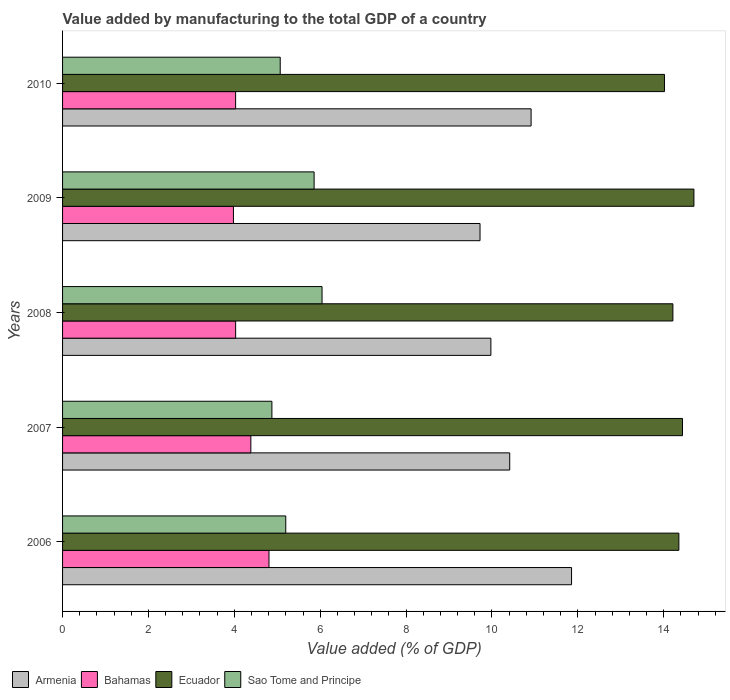How many different coloured bars are there?
Offer a very short reply. 4. How many groups of bars are there?
Your response must be concise. 5. How many bars are there on the 1st tick from the top?
Your answer should be very brief. 4. What is the value added by manufacturing to the total GDP in Ecuador in 2008?
Make the answer very short. 14.21. Across all years, what is the maximum value added by manufacturing to the total GDP in Bahamas?
Your answer should be very brief. 4.81. Across all years, what is the minimum value added by manufacturing to the total GDP in Ecuador?
Keep it short and to the point. 14.02. In which year was the value added by manufacturing to the total GDP in Armenia maximum?
Offer a very short reply. 2006. What is the total value added by manufacturing to the total GDP in Sao Tome and Principe in the graph?
Give a very brief answer. 27.04. What is the difference between the value added by manufacturing to the total GDP in Sao Tome and Principe in 2009 and that in 2010?
Your response must be concise. 0.79. What is the difference between the value added by manufacturing to the total GDP in Bahamas in 2010 and the value added by manufacturing to the total GDP in Sao Tome and Principe in 2008?
Your answer should be very brief. -2.01. What is the average value added by manufacturing to the total GDP in Sao Tome and Principe per year?
Ensure brevity in your answer.  5.41. In the year 2009, what is the difference between the value added by manufacturing to the total GDP in Sao Tome and Principe and value added by manufacturing to the total GDP in Armenia?
Provide a short and direct response. -3.86. What is the ratio of the value added by manufacturing to the total GDP in Ecuador in 2006 to that in 2010?
Your response must be concise. 1.02. What is the difference between the highest and the second highest value added by manufacturing to the total GDP in Sao Tome and Principe?
Offer a very short reply. 0.18. What is the difference between the highest and the lowest value added by manufacturing to the total GDP in Bahamas?
Your response must be concise. 0.83. What does the 1st bar from the top in 2010 represents?
Offer a very short reply. Sao Tome and Principe. What does the 1st bar from the bottom in 2007 represents?
Give a very brief answer. Armenia. How many bars are there?
Give a very brief answer. 20. What is the difference between two consecutive major ticks on the X-axis?
Offer a very short reply. 2. Does the graph contain any zero values?
Make the answer very short. No. Where does the legend appear in the graph?
Your answer should be compact. Bottom left. How many legend labels are there?
Your answer should be compact. 4. What is the title of the graph?
Ensure brevity in your answer.  Value added by manufacturing to the total GDP of a country. Does "Palau" appear as one of the legend labels in the graph?
Give a very brief answer. No. What is the label or title of the X-axis?
Provide a short and direct response. Value added (% of GDP). What is the Value added (% of GDP) in Armenia in 2006?
Provide a short and direct response. 11.85. What is the Value added (% of GDP) in Bahamas in 2006?
Offer a terse response. 4.81. What is the Value added (% of GDP) in Ecuador in 2006?
Your answer should be compact. 14.35. What is the Value added (% of GDP) of Sao Tome and Principe in 2006?
Offer a very short reply. 5.2. What is the Value added (% of GDP) of Armenia in 2007?
Offer a terse response. 10.41. What is the Value added (% of GDP) in Bahamas in 2007?
Give a very brief answer. 4.38. What is the Value added (% of GDP) of Ecuador in 2007?
Give a very brief answer. 14.44. What is the Value added (% of GDP) of Sao Tome and Principe in 2007?
Offer a terse response. 4.88. What is the Value added (% of GDP) in Armenia in 2008?
Give a very brief answer. 9.98. What is the Value added (% of GDP) in Bahamas in 2008?
Provide a succinct answer. 4.03. What is the Value added (% of GDP) in Ecuador in 2008?
Offer a very short reply. 14.21. What is the Value added (% of GDP) in Sao Tome and Principe in 2008?
Your answer should be very brief. 6.04. What is the Value added (% of GDP) in Armenia in 2009?
Offer a very short reply. 9.72. What is the Value added (% of GDP) in Bahamas in 2009?
Your answer should be very brief. 3.98. What is the Value added (% of GDP) in Ecuador in 2009?
Offer a very short reply. 14.7. What is the Value added (% of GDP) in Sao Tome and Principe in 2009?
Your answer should be very brief. 5.86. What is the Value added (% of GDP) of Armenia in 2010?
Make the answer very short. 10.91. What is the Value added (% of GDP) in Bahamas in 2010?
Give a very brief answer. 4.03. What is the Value added (% of GDP) in Ecuador in 2010?
Your answer should be compact. 14.02. What is the Value added (% of GDP) of Sao Tome and Principe in 2010?
Offer a terse response. 5.07. Across all years, what is the maximum Value added (% of GDP) of Armenia?
Provide a short and direct response. 11.85. Across all years, what is the maximum Value added (% of GDP) of Bahamas?
Offer a very short reply. 4.81. Across all years, what is the maximum Value added (% of GDP) in Ecuador?
Provide a succinct answer. 14.7. Across all years, what is the maximum Value added (% of GDP) in Sao Tome and Principe?
Offer a terse response. 6.04. Across all years, what is the minimum Value added (% of GDP) in Armenia?
Give a very brief answer. 9.72. Across all years, what is the minimum Value added (% of GDP) in Bahamas?
Provide a succinct answer. 3.98. Across all years, what is the minimum Value added (% of GDP) of Ecuador?
Give a very brief answer. 14.02. Across all years, what is the minimum Value added (% of GDP) in Sao Tome and Principe?
Offer a terse response. 4.88. What is the total Value added (% of GDP) of Armenia in the graph?
Keep it short and to the point. 52.88. What is the total Value added (% of GDP) in Bahamas in the graph?
Provide a short and direct response. 21.23. What is the total Value added (% of GDP) of Ecuador in the graph?
Provide a short and direct response. 71.73. What is the total Value added (% of GDP) of Sao Tome and Principe in the graph?
Offer a very short reply. 27.04. What is the difference between the Value added (% of GDP) in Armenia in 2006 and that in 2007?
Your response must be concise. 1.44. What is the difference between the Value added (% of GDP) of Bahamas in 2006 and that in 2007?
Make the answer very short. 0.42. What is the difference between the Value added (% of GDP) in Ecuador in 2006 and that in 2007?
Ensure brevity in your answer.  -0.08. What is the difference between the Value added (% of GDP) of Sao Tome and Principe in 2006 and that in 2007?
Give a very brief answer. 0.32. What is the difference between the Value added (% of GDP) of Armenia in 2006 and that in 2008?
Provide a short and direct response. 1.88. What is the difference between the Value added (% of GDP) in Bahamas in 2006 and that in 2008?
Provide a short and direct response. 0.78. What is the difference between the Value added (% of GDP) of Ecuador in 2006 and that in 2008?
Provide a short and direct response. 0.14. What is the difference between the Value added (% of GDP) of Sao Tome and Principe in 2006 and that in 2008?
Provide a succinct answer. -0.84. What is the difference between the Value added (% of GDP) of Armenia in 2006 and that in 2009?
Ensure brevity in your answer.  2.13. What is the difference between the Value added (% of GDP) in Bahamas in 2006 and that in 2009?
Your response must be concise. 0.83. What is the difference between the Value added (% of GDP) in Ecuador in 2006 and that in 2009?
Your answer should be very brief. -0.35. What is the difference between the Value added (% of GDP) in Sao Tome and Principe in 2006 and that in 2009?
Ensure brevity in your answer.  -0.66. What is the difference between the Value added (% of GDP) in Armenia in 2006 and that in 2010?
Provide a succinct answer. 0.94. What is the difference between the Value added (% of GDP) in Bahamas in 2006 and that in 2010?
Your answer should be compact. 0.78. What is the difference between the Value added (% of GDP) in Ecuador in 2006 and that in 2010?
Provide a succinct answer. 0.34. What is the difference between the Value added (% of GDP) in Sao Tome and Principe in 2006 and that in 2010?
Give a very brief answer. 0.13. What is the difference between the Value added (% of GDP) of Armenia in 2007 and that in 2008?
Your answer should be compact. 0.44. What is the difference between the Value added (% of GDP) of Bahamas in 2007 and that in 2008?
Provide a short and direct response. 0.35. What is the difference between the Value added (% of GDP) of Ecuador in 2007 and that in 2008?
Provide a succinct answer. 0.22. What is the difference between the Value added (% of GDP) in Sao Tome and Principe in 2007 and that in 2008?
Give a very brief answer. -1.17. What is the difference between the Value added (% of GDP) in Armenia in 2007 and that in 2009?
Offer a terse response. 0.69. What is the difference between the Value added (% of GDP) in Bahamas in 2007 and that in 2009?
Ensure brevity in your answer.  0.41. What is the difference between the Value added (% of GDP) in Ecuador in 2007 and that in 2009?
Your answer should be compact. -0.27. What is the difference between the Value added (% of GDP) in Sao Tome and Principe in 2007 and that in 2009?
Keep it short and to the point. -0.98. What is the difference between the Value added (% of GDP) of Armenia in 2007 and that in 2010?
Your response must be concise. -0.5. What is the difference between the Value added (% of GDP) in Bahamas in 2007 and that in 2010?
Make the answer very short. 0.35. What is the difference between the Value added (% of GDP) in Ecuador in 2007 and that in 2010?
Keep it short and to the point. 0.42. What is the difference between the Value added (% of GDP) in Sao Tome and Principe in 2007 and that in 2010?
Ensure brevity in your answer.  -0.19. What is the difference between the Value added (% of GDP) of Armenia in 2008 and that in 2009?
Offer a very short reply. 0.25. What is the difference between the Value added (% of GDP) in Bahamas in 2008 and that in 2009?
Provide a short and direct response. 0.05. What is the difference between the Value added (% of GDP) in Ecuador in 2008 and that in 2009?
Offer a very short reply. -0.49. What is the difference between the Value added (% of GDP) in Sao Tome and Principe in 2008 and that in 2009?
Your response must be concise. 0.18. What is the difference between the Value added (% of GDP) in Armenia in 2008 and that in 2010?
Ensure brevity in your answer.  -0.94. What is the difference between the Value added (% of GDP) in Ecuador in 2008 and that in 2010?
Give a very brief answer. 0.2. What is the difference between the Value added (% of GDP) of Sao Tome and Principe in 2008 and that in 2010?
Your answer should be compact. 0.97. What is the difference between the Value added (% of GDP) of Armenia in 2009 and that in 2010?
Make the answer very short. -1.19. What is the difference between the Value added (% of GDP) of Bahamas in 2009 and that in 2010?
Ensure brevity in your answer.  -0.05. What is the difference between the Value added (% of GDP) in Ecuador in 2009 and that in 2010?
Provide a short and direct response. 0.69. What is the difference between the Value added (% of GDP) in Sao Tome and Principe in 2009 and that in 2010?
Your response must be concise. 0.79. What is the difference between the Value added (% of GDP) in Armenia in 2006 and the Value added (% of GDP) in Bahamas in 2007?
Your response must be concise. 7.47. What is the difference between the Value added (% of GDP) in Armenia in 2006 and the Value added (% of GDP) in Ecuador in 2007?
Provide a succinct answer. -2.58. What is the difference between the Value added (% of GDP) of Armenia in 2006 and the Value added (% of GDP) of Sao Tome and Principe in 2007?
Your answer should be very brief. 6.98. What is the difference between the Value added (% of GDP) in Bahamas in 2006 and the Value added (% of GDP) in Ecuador in 2007?
Give a very brief answer. -9.63. What is the difference between the Value added (% of GDP) of Bahamas in 2006 and the Value added (% of GDP) of Sao Tome and Principe in 2007?
Offer a terse response. -0.07. What is the difference between the Value added (% of GDP) of Ecuador in 2006 and the Value added (% of GDP) of Sao Tome and Principe in 2007?
Ensure brevity in your answer.  9.48. What is the difference between the Value added (% of GDP) in Armenia in 2006 and the Value added (% of GDP) in Bahamas in 2008?
Your answer should be very brief. 7.82. What is the difference between the Value added (% of GDP) of Armenia in 2006 and the Value added (% of GDP) of Ecuador in 2008?
Provide a succinct answer. -2.36. What is the difference between the Value added (% of GDP) of Armenia in 2006 and the Value added (% of GDP) of Sao Tome and Principe in 2008?
Make the answer very short. 5.81. What is the difference between the Value added (% of GDP) of Bahamas in 2006 and the Value added (% of GDP) of Ecuador in 2008?
Ensure brevity in your answer.  -9.41. What is the difference between the Value added (% of GDP) of Bahamas in 2006 and the Value added (% of GDP) of Sao Tome and Principe in 2008?
Ensure brevity in your answer.  -1.24. What is the difference between the Value added (% of GDP) of Ecuador in 2006 and the Value added (% of GDP) of Sao Tome and Principe in 2008?
Give a very brief answer. 8.31. What is the difference between the Value added (% of GDP) in Armenia in 2006 and the Value added (% of GDP) in Bahamas in 2009?
Ensure brevity in your answer.  7.87. What is the difference between the Value added (% of GDP) in Armenia in 2006 and the Value added (% of GDP) in Ecuador in 2009?
Offer a very short reply. -2.85. What is the difference between the Value added (% of GDP) of Armenia in 2006 and the Value added (% of GDP) of Sao Tome and Principe in 2009?
Your answer should be compact. 6. What is the difference between the Value added (% of GDP) in Bahamas in 2006 and the Value added (% of GDP) in Ecuador in 2009?
Offer a terse response. -9.9. What is the difference between the Value added (% of GDP) of Bahamas in 2006 and the Value added (% of GDP) of Sao Tome and Principe in 2009?
Make the answer very short. -1.05. What is the difference between the Value added (% of GDP) in Ecuador in 2006 and the Value added (% of GDP) in Sao Tome and Principe in 2009?
Offer a terse response. 8.49. What is the difference between the Value added (% of GDP) in Armenia in 2006 and the Value added (% of GDP) in Bahamas in 2010?
Your answer should be compact. 7.82. What is the difference between the Value added (% of GDP) in Armenia in 2006 and the Value added (% of GDP) in Ecuador in 2010?
Your answer should be very brief. -2.16. What is the difference between the Value added (% of GDP) in Armenia in 2006 and the Value added (% of GDP) in Sao Tome and Principe in 2010?
Make the answer very short. 6.78. What is the difference between the Value added (% of GDP) of Bahamas in 2006 and the Value added (% of GDP) of Ecuador in 2010?
Provide a short and direct response. -9.21. What is the difference between the Value added (% of GDP) of Bahamas in 2006 and the Value added (% of GDP) of Sao Tome and Principe in 2010?
Give a very brief answer. -0.26. What is the difference between the Value added (% of GDP) of Ecuador in 2006 and the Value added (% of GDP) of Sao Tome and Principe in 2010?
Provide a succinct answer. 9.28. What is the difference between the Value added (% of GDP) of Armenia in 2007 and the Value added (% of GDP) of Bahamas in 2008?
Your response must be concise. 6.38. What is the difference between the Value added (% of GDP) of Armenia in 2007 and the Value added (% of GDP) of Ecuador in 2008?
Make the answer very short. -3.8. What is the difference between the Value added (% of GDP) in Armenia in 2007 and the Value added (% of GDP) in Sao Tome and Principe in 2008?
Give a very brief answer. 4.37. What is the difference between the Value added (% of GDP) of Bahamas in 2007 and the Value added (% of GDP) of Ecuador in 2008?
Offer a terse response. -9.83. What is the difference between the Value added (% of GDP) of Bahamas in 2007 and the Value added (% of GDP) of Sao Tome and Principe in 2008?
Your answer should be compact. -1.66. What is the difference between the Value added (% of GDP) in Ecuador in 2007 and the Value added (% of GDP) in Sao Tome and Principe in 2008?
Keep it short and to the point. 8.39. What is the difference between the Value added (% of GDP) in Armenia in 2007 and the Value added (% of GDP) in Bahamas in 2009?
Keep it short and to the point. 6.43. What is the difference between the Value added (% of GDP) of Armenia in 2007 and the Value added (% of GDP) of Ecuador in 2009?
Offer a terse response. -4.29. What is the difference between the Value added (% of GDP) of Armenia in 2007 and the Value added (% of GDP) of Sao Tome and Principe in 2009?
Ensure brevity in your answer.  4.56. What is the difference between the Value added (% of GDP) in Bahamas in 2007 and the Value added (% of GDP) in Ecuador in 2009?
Make the answer very short. -10.32. What is the difference between the Value added (% of GDP) of Bahamas in 2007 and the Value added (% of GDP) of Sao Tome and Principe in 2009?
Offer a very short reply. -1.47. What is the difference between the Value added (% of GDP) of Ecuador in 2007 and the Value added (% of GDP) of Sao Tome and Principe in 2009?
Your answer should be very brief. 8.58. What is the difference between the Value added (% of GDP) in Armenia in 2007 and the Value added (% of GDP) in Bahamas in 2010?
Offer a terse response. 6.38. What is the difference between the Value added (% of GDP) in Armenia in 2007 and the Value added (% of GDP) in Ecuador in 2010?
Your answer should be very brief. -3.6. What is the difference between the Value added (% of GDP) of Armenia in 2007 and the Value added (% of GDP) of Sao Tome and Principe in 2010?
Ensure brevity in your answer.  5.34. What is the difference between the Value added (% of GDP) of Bahamas in 2007 and the Value added (% of GDP) of Ecuador in 2010?
Your response must be concise. -9.63. What is the difference between the Value added (% of GDP) of Bahamas in 2007 and the Value added (% of GDP) of Sao Tome and Principe in 2010?
Your response must be concise. -0.68. What is the difference between the Value added (% of GDP) in Ecuador in 2007 and the Value added (% of GDP) in Sao Tome and Principe in 2010?
Your response must be concise. 9.37. What is the difference between the Value added (% of GDP) of Armenia in 2008 and the Value added (% of GDP) of Bahamas in 2009?
Give a very brief answer. 6. What is the difference between the Value added (% of GDP) in Armenia in 2008 and the Value added (% of GDP) in Ecuador in 2009?
Your response must be concise. -4.73. What is the difference between the Value added (% of GDP) in Armenia in 2008 and the Value added (% of GDP) in Sao Tome and Principe in 2009?
Offer a terse response. 4.12. What is the difference between the Value added (% of GDP) in Bahamas in 2008 and the Value added (% of GDP) in Ecuador in 2009?
Ensure brevity in your answer.  -10.67. What is the difference between the Value added (% of GDP) in Bahamas in 2008 and the Value added (% of GDP) in Sao Tome and Principe in 2009?
Ensure brevity in your answer.  -1.83. What is the difference between the Value added (% of GDP) of Ecuador in 2008 and the Value added (% of GDP) of Sao Tome and Principe in 2009?
Your response must be concise. 8.36. What is the difference between the Value added (% of GDP) of Armenia in 2008 and the Value added (% of GDP) of Bahamas in 2010?
Your answer should be very brief. 5.94. What is the difference between the Value added (% of GDP) of Armenia in 2008 and the Value added (% of GDP) of Ecuador in 2010?
Offer a terse response. -4.04. What is the difference between the Value added (% of GDP) in Armenia in 2008 and the Value added (% of GDP) in Sao Tome and Principe in 2010?
Offer a terse response. 4.91. What is the difference between the Value added (% of GDP) in Bahamas in 2008 and the Value added (% of GDP) in Ecuador in 2010?
Make the answer very short. -9.99. What is the difference between the Value added (% of GDP) of Bahamas in 2008 and the Value added (% of GDP) of Sao Tome and Principe in 2010?
Give a very brief answer. -1.04. What is the difference between the Value added (% of GDP) in Ecuador in 2008 and the Value added (% of GDP) in Sao Tome and Principe in 2010?
Your answer should be compact. 9.14. What is the difference between the Value added (% of GDP) of Armenia in 2009 and the Value added (% of GDP) of Bahamas in 2010?
Your answer should be compact. 5.69. What is the difference between the Value added (% of GDP) in Armenia in 2009 and the Value added (% of GDP) in Ecuador in 2010?
Make the answer very short. -4.3. What is the difference between the Value added (% of GDP) in Armenia in 2009 and the Value added (% of GDP) in Sao Tome and Principe in 2010?
Your response must be concise. 4.65. What is the difference between the Value added (% of GDP) in Bahamas in 2009 and the Value added (% of GDP) in Ecuador in 2010?
Your answer should be compact. -10.04. What is the difference between the Value added (% of GDP) in Bahamas in 2009 and the Value added (% of GDP) in Sao Tome and Principe in 2010?
Make the answer very short. -1.09. What is the difference between the Value added (% of GDP) in Ecuador in 2009 and the Value added (% of GDP) in Sao Tome and Principe in 2010?
Offer a terse response. 9.63. What is the average Value added (% of GDP) in Armenia per year?
Your response must be concise. 10.58. What is the average Value added (% of GDP) of Bahamas per year?
Give a very brief answer. 4.25. What is the average Value added (% of GDP) of Ecuador per year?
Provide a succinct answer. 14.35. What is the average Value added (% of GDP) in Sao Tome and Principe per year?
Your answer should be very brief. 5.41. In the year 2006, what is the difference between the Value added (% of GDP) of Armenia and Value added (% of GDP) of Bahamas?
Your response must be concise. 7.05. In the year 2006, what is the difference between the Value added (% of GDP) in Armenia and Value added (% of GDP) in Ecuador?
Keep it short and to the point. -2.5. In the year 2006, what is the difference between the Value added (% of GDP) in Armenia and Value added (% of GDP) in Sao Tome and Principe?
Provide a short and direct response. 6.66. In the year 2006, what is the difference between the Value added (% of GDP) in Bahamas and Value added (% of GDP) in Ecuador?
Ensure brevity in your answer.  -9.55. In the year 2006, what is the difference between the Value added (% of GDP) of Bahamas and Value added (% of GDP) of Sao Tome and Principe?
Keep it short and to the point. -0.39. In the year 2006, what is the difference between the Value added (% of GDP) of Ecuador and Value added (% of GDP) of Sao Tome and Principe?
Provide a short and direct response. 9.16. In the year 2007, what is the difference between the Value added (% of GDP) in Armenia and Value added (% of GDP) in Bahamas?
Ensure brevity in your answer.  6.03. In the year 2007, what is the difference between the Value added (% of GDP) in Armenia and Value added (% of GDP) in Ecuador?
Keep it short and to the point. -4.02. In the year 2007, what is the difference between the Value added (% of GDP) of Armenia and Value added (% of GDP) of Sao Tome and Principe?
Your answer should be very brief. 5.54. In the year 2007, what is the difference between the Value added (% of GDP) in Bahamas and Value added (% of GDP) in Ecuador?
Keep it short and to the point. -10.05. In the year 2007, what is the difference between the Value added (% of GDP) of Bahamas and Value added (% of GDP) of Sao Tome and Principe?
Ensure brevity in your answer.  -0.49. In the year 2007, what is the difference between the Value added (% of GDP) of Ecuador and Value added (% of GDP) of Sao Tome and Principe?
Keep it short and to the point. 9.56. In the year 2008, what is the difference between the Value added (% of GDP) in Armenia and Value added (% of GDP) in Bahamas?
Provide a short and direct response. 5.94. In the year 2008, what is the difference between the Value added (% of GDP) in Armenia and Value added (% of GDP) in Ecuador?
Make the answer very short. -4.24. In the year 2008, what is the difference between the Value added (% of GDP) in Armenia and Value added (% of GDP) in Sao Tome and Principe?
Your response must be concise. 3.93. In the year 2008, what is the difference between the Value added (% of GDP) in Bahamas and Value added (% of GDP) in Ecuador?
Your response must be concise. -10.18. In the year 2008, what is the difference between the Value added (% of GDP) in Bahamas and Value added (% of GDP) in Sao Tome and Principe?
Your response must be concise. -2.01. In the year 2008, what is the difference between the Value added (% of GDP) in Ecuador and Value added (% of GDP) in Sao Tome and Principe?
Offer a terse response. 8.17. In the year 2009, what is the difference between the Value added (% of GDP) in Armenia and Value added (% of GDP) in Bahamas?
Offer a very short reply. 5.74. In the year 2009, what is the difference between the Value added (% of GDP) of Armenia and Value added (% of GDP) of Ecuador?
Provide a succinct answer. -4.98. In the year 2009, what is the difference between the Value added (% of GDP) in Armenia and Value added (% of GDP) in Sao Tome and Principe?
Keep it short and to the point. 3.86. In the year 2009, what is the difference between the Value added (% of GDP) of Bahamas and Value added (% of GDP) of Ecuador?
Make the answer very short. -10.72. In the year 2009, what is the difference between the Value added (% of GDP) of Bahamas and Value added (% of GDP) of Sao Tome and Principe?
Your response must be concise. -1.88. In the year 2009, what is the difference between the Value added (% of GDP) of Ecuador and Value added (% of GDP) of Sao Tome and Principe?
Provide a short and direct response. 8.85. In the year 2010, what is the difference between the Value added (% of GDP) of Armenia and Value added (% of GDP) of Bahamas?
Your answer should be very brief. 6.88. In the year 2010, what is the difference between the Value added (% of GDP) of Armenia and Value added (% of GDP) of Ecuador?
Ensure brevity in your answer.  -3.11. In the year 2010, what is the difference between the Value added (% of GDP) of Armenia and Value added (% of GDP) of Sao Tome and Principe?
Your response must be concise. 5.84. In the year 2010, what is the difference between the Value added (% of GDP) of Bahamas and Value added (% of GDP) of Ecuador?
Your response must be concise. -9.99. In the year 2010, what is the difference between the Value added (% of GDP) in Bahamas and Value added (% of GDP) in Sao Tome and Principe?
Make the answer very short. -1.04. In the year 2010, what is the difference between the Value added (% of GDP) of Ecuador and Value added (% of GDP) of Sao Tome and Principe?
Keep it short and to the point. 8.95. What is the ratio of the Value added (% of GDP) of Armenia in 2006 to that in 2007?
Provide a short and direct response. 1.14. What is the ratio of the Value added (% of GDP) in Bahamas in 2006 to that in 2007?
Your answer should be very brief. 1.1. What is the ratio of the Value added (% of GDP) in Ecuador in 2006 to that in 2007?
Offer a terse response. 0.99. What is the ratio of the Value added (% of GDP) in Sao Tome and Principe in 2006 to that in 2007?
Provide a short and direct response. 1.07. What is the ratio of the Value added (% of GDP) of Armenia in 2006 to that in 2008?
Offer a very short reply. 1.19. What is the ratio of the Value added (% of GDP) of Bahamas in 2006 to that in 2008?
Provide a succinct answer. 1.19. What is the ratio of the Value added (% of GDP) in Ecuador in 2006 to that in 2008?
Your response must be concise. 1.01. What is the ratio of the Value added (% of GDP) in Sao Tome and Principe in 2006 to that in 2008?
Your answer should be compact. 0.86. What is the ratio of the Value added (% of GDP) in Armenia in 2006 to that in 2009?
Your response must be concise. 1.22. What is the ratio of the Value added (% of GDP) in Bahamas in 2006 to that in 2009?
Make the answer very short. 1.21. What is the ratio of the Value added (% of GDP) in Ecuador in 2006 to that in 2009?
Ensure brevity in your answer.  0.98. What is the ratio of the Value added (% of GDP) of Sao Tome and Principe in 2006 to that in 2009?
Make the answer very short. 0.89. What is the ratio of the Value added (% of GDP) in Armenia in 2006 to that in 2010?
Provide a succinct answer. 1.09. What is the ratio of the Value added (% of GDP) in Bahamas in 2006 to that in 2010?
Your response must be concise. 1.19. What is the ratio of the Value added (% of GDP) of Ecuador in 2006 to that in 2010?
Provide a short and direct response. 1.02. What is the ratio of the Value added (% of GDP) in Sao Tome and Principe in 2006 to that in 2010?
Ensure brevity in your answer.  1.03. What is the ratio of the Value added (% of GDP) in Armenia in 2007 to that in 2008?
Ensure brevity in your answer.  1.04. What is the ratio of the Value added (% of GDP) of Bahamas in 2007 to that in 2008?
Make the answer very short. 1.09. What is the ratio of the Value added (% of GDP) of Ecuador in 2007 to that in 2008?
Ensure brevity in your answer.  1.02. What is the ratio of the Value added (% of GDP) of Sao Tome and Principe in 2007 to that in 2008?
Offer a terse response. 0.81. What is the ratio of the Value added (% of GDP) of Armenia in 2007 to that in 2009?
Ensure brevity in your answer.  1.07. What is the ratio of the Value added (% of GDP) in Bahamas in 2007 to that in 2009?
Keep it short and to the point. 1.1. What is the ratio of the Value added (% of GDP) of Ecuador in 2007 to that in 2009?
Offer a very short reply. 0.98. What is the ratio of the Value added (% of GDP) in Sao Tome and Principe in 2007 to that in 2009?
Make the answer very short. 0.83. What is the ratio of the Value added (% of GDP) of Armenia in 2007 to that in 2010?
Keep it short and to the point. 0.95. What is the ratio of the Value added (% of GDP) of Bahamas in 2007 to that in 2010?
Make the answer very short. 1.09. What is the ratio of the Value added (% of GDP) in Ecuador in 2007 to that in 2010?
Provide a succinct answer. 1.03. What is the ratio of the Value added (% of GDP) of Sao Tome and Principe in 2007 to that in 2010?
Give a very brief answer. 0.96. What is the ratio of the Value added (% of GDP) of Bahamas in 2008 to that in 2009?
Offer a terse response. 1.01. What is the ratio of the Value added (% of GDP) in Ecuador in 2008 to that in 2009?
Ensure brevity in your answer.  0.97. What is the ratio of the Value added (% of GDP) in Sao Tome and Principe in 2008 to that in 2009?
Make the answer very short. 1.03. What is the ratio of the Value added (% of GDP) of Armenia in 2008 to that in 2010?
Give a very brief answer. 0.91. What is the ratio of the Value added (% of GDP) in Bahamas in 2008 to that in 2010?
Keep it short and to the point. 1. What is the ratio of the Value added (% of GDP) in Ecuador in 2008 to that in 2010?
Provide a short and direct response. 1.01. What is the ratio of the Value added (% of GDP) of Sao Tome and Principe in 2008 to that in 2010?
Provide a short and direct response. 1.19. What is the ratio of the Value added (% of GDP) in Armenia in 2009 to that in 2010?
Provide a short and direct response. 0.89. What is the ratio of the Value added (% of GDP) in Bahamas in 2009 to that in 2010?
Your response must be concise. 0.99. What is the ratio of the Value added (% of GDP) in Ecuador in 2009 to that in 2010?
Keep it short and to the point. 1.05. What is the ratio of the Value added (% of GDP) of Sao Tome and Principe in 2009 to that in 2010?
Your response must be concise. 1.16. What is the difference between the highest and the second highest Value added (% of GDP) in Armenia?
Ensure brevity in your answer.  0.94. What is the difference between the highest and the second highest Value added (% of GDP) of Bahamas?
Your answer should be very brief. 0.42. What is the difference between the highest and the second highest Value added (% of GDP) in Ecuador?
Offer a terse response. 0.27. What is the difference between the highest and the second highest Value added (% of GDP) in Sao Tome and Principe?
Keep it short and to the point. 0.18. What is the difference between the highest and the lowest Value added (% of GDP) of Armenia?
Give a very brief answer. 2.13. What is the difference between the highest and the lowest Value added (% of GDP) of Bahamas?
Provide a short and direct response. 0.83. What is the difference between the highest and the lowest Value added (% of GDP) in Ecuador?
Ensure brevity in your answer.  0.69. What is the difference between the highest and the lowest Value added (% of GDP) of Sao Tome and Principe?
Give a very brief answer. 1.17. 